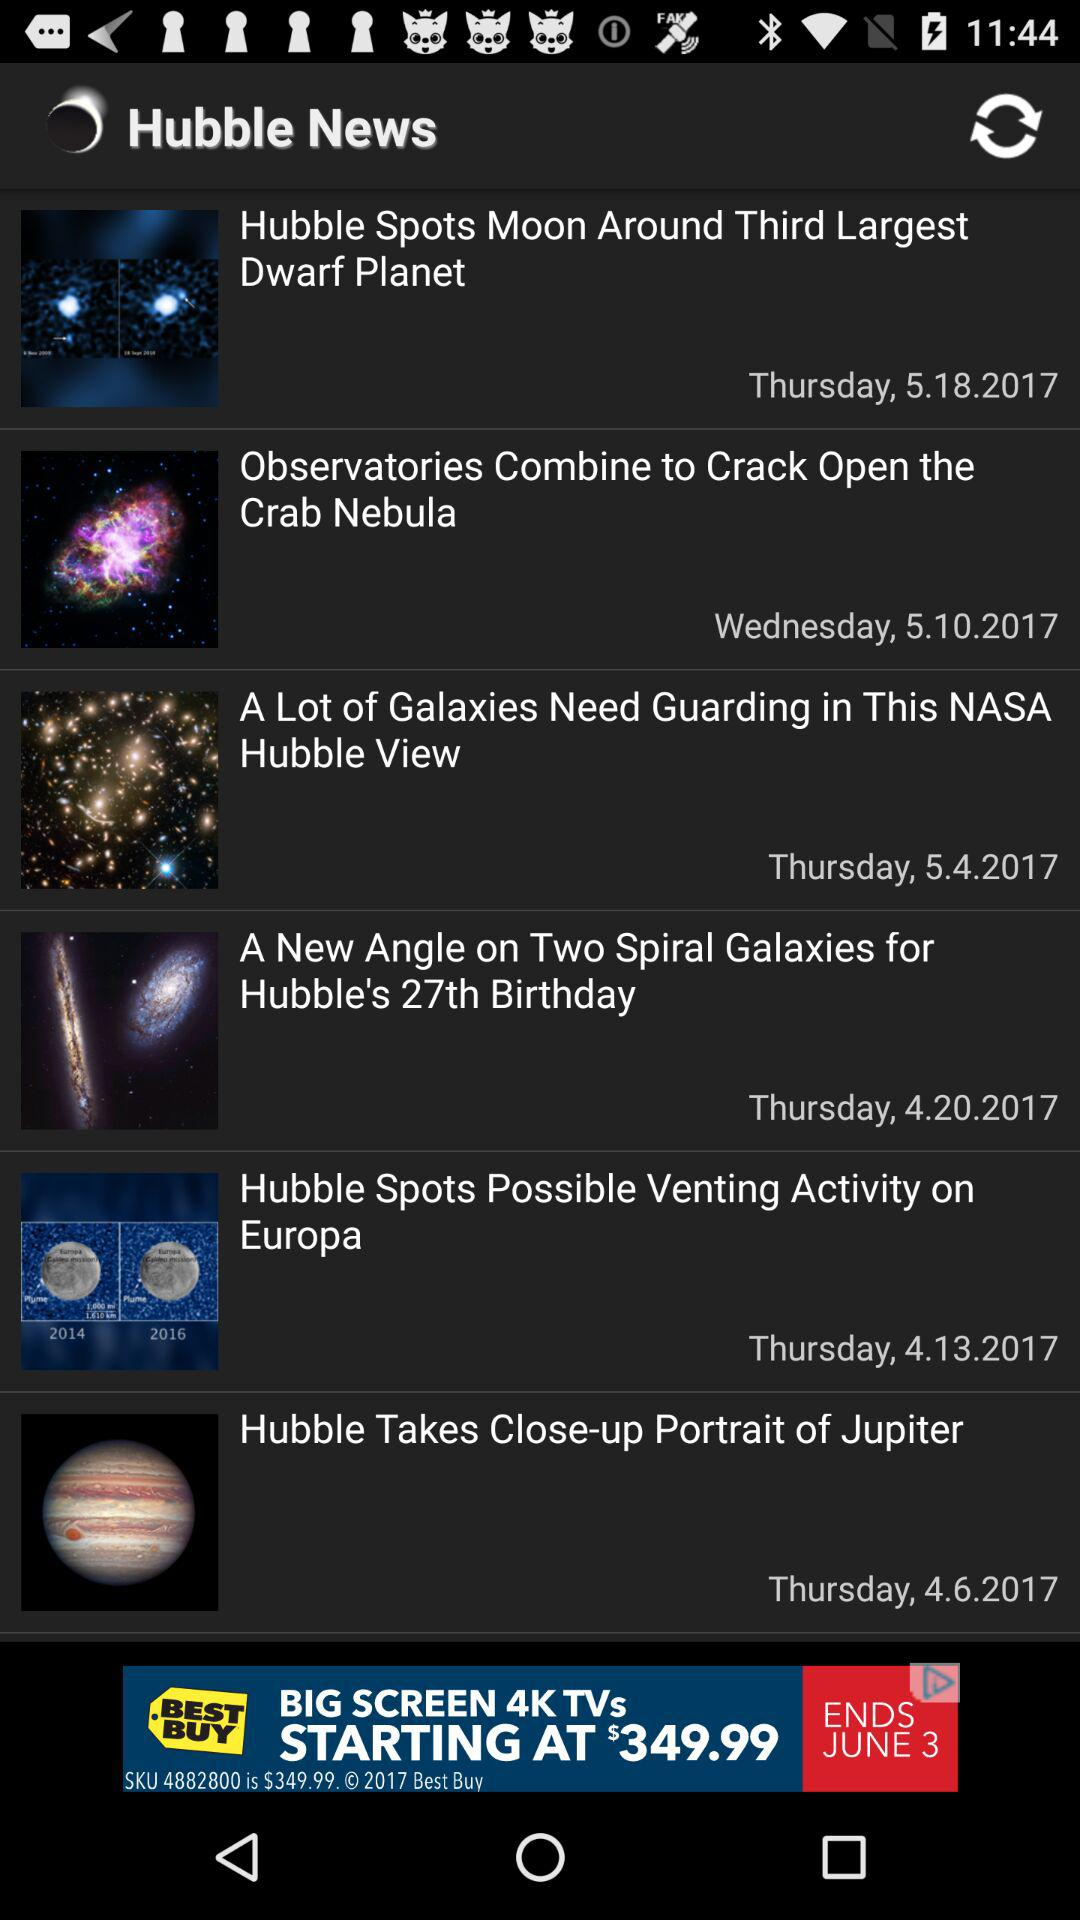When was the "Hubble Spots Moon Around Third Largest Dwarf Planet" news published? The news was published on Thursday, May 18, 2017. 